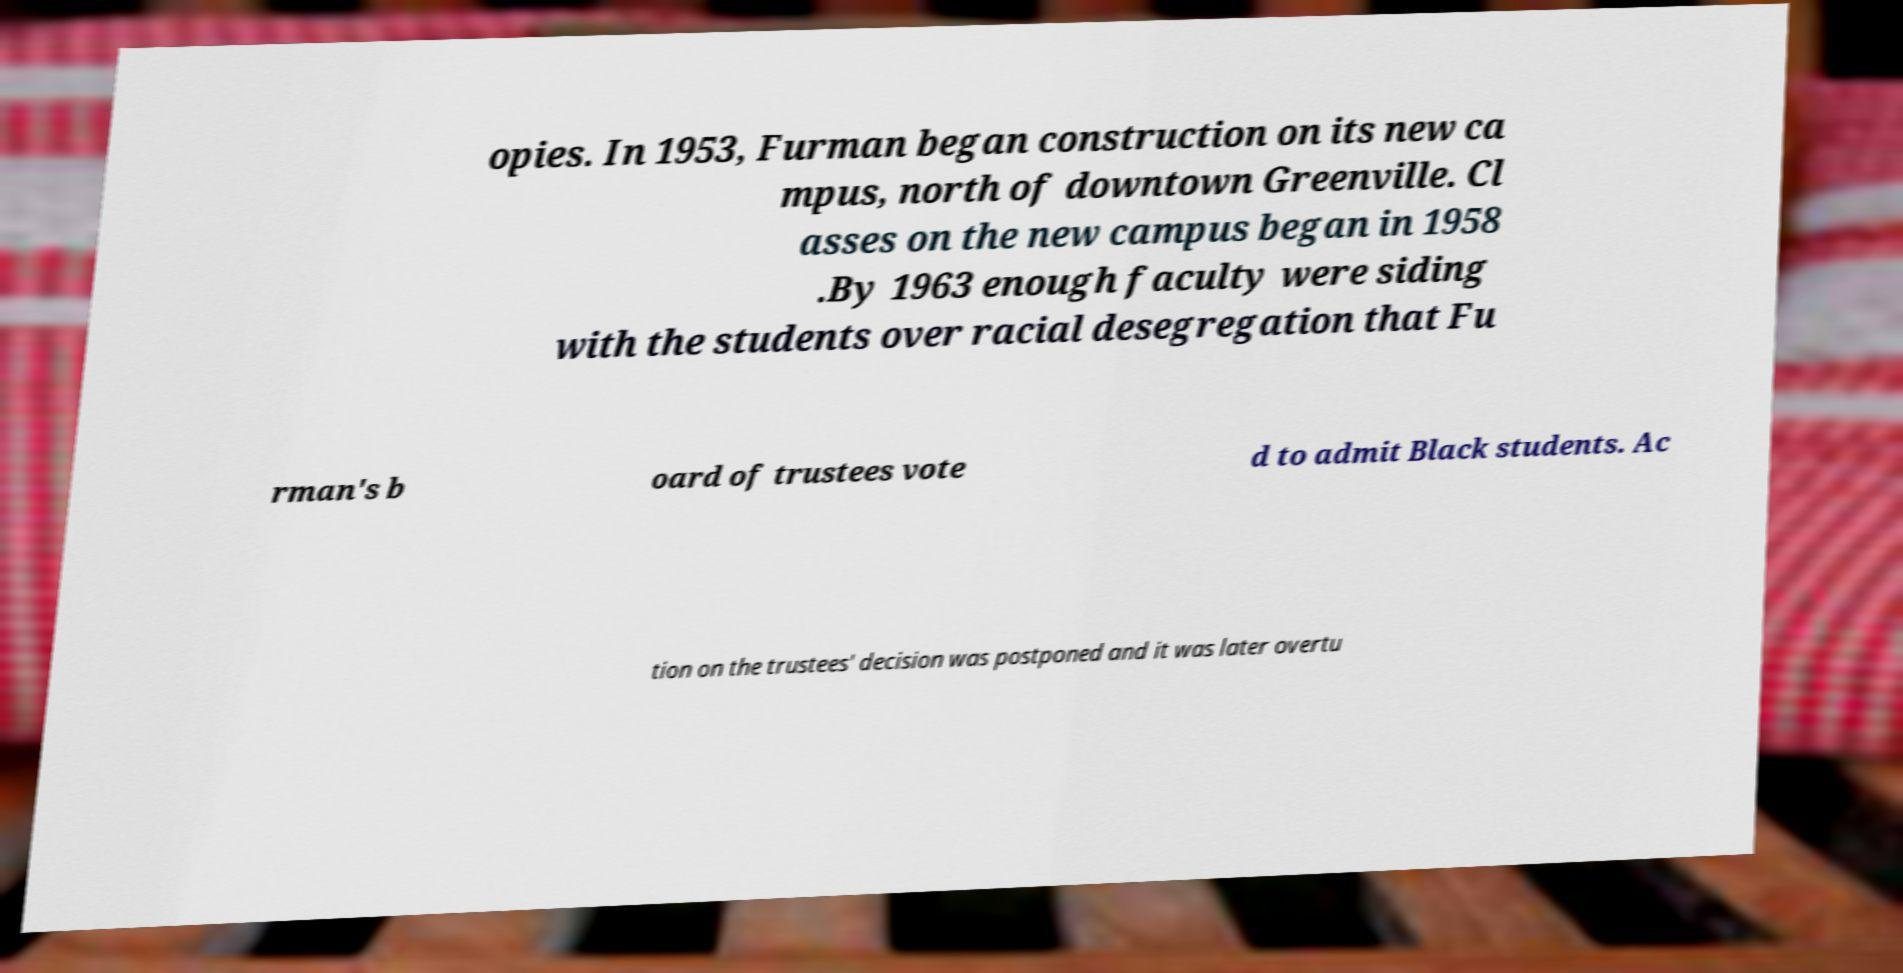Could you assist in decoding the text presented in this image and type it out clearly? opies. In 1953, Furman began construction on its new ca mpus, north of downtown Greenville. Cl asses on the new campus began in 1958 .By 1963 enough faculty were siding with the students over racial desegregation that Fu rman's b oard of trustees vote d to admit Black students. Ac tion on the trustees' decision was postponed and it was later overtu 